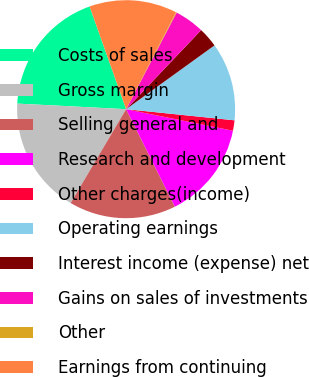Convert chart. <chart><loc_0><loc_0><loc_500><loc_500><pie_chart><fcel>Costs of sales<fcel>Gross margin<fcel>Selling general and<fcel>Research and development<fcel>Other charges(income)<fcel>Operating earnings<fcel>Interest income (expense) net<fcel>Gains on sales of investments<fcel>Other<fcel>Earnings from continuing<nl><fcel>18.75%<fcel>17.32%<fcel>15.88%<fcel>14.45%<fcel>1.54%<fcel>11.58%<fcel>2.97%<fcel>4.41%<fcel>0.1%<fcel>13.01%<nl></chart> 